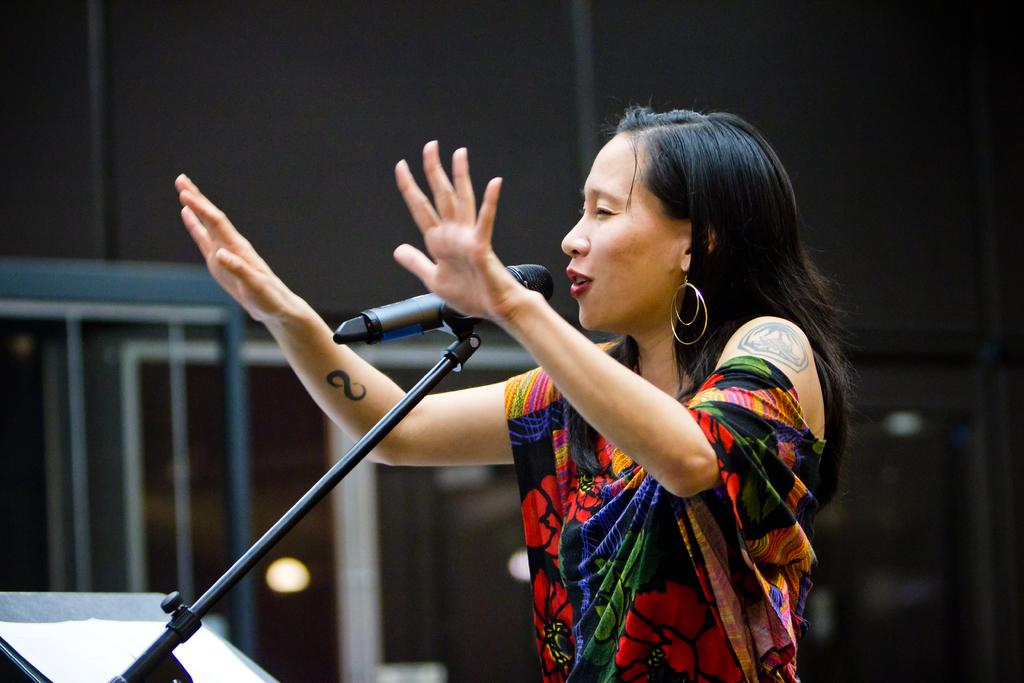Who is the main subject in the image? There is a lady in the image. What is the lady wearing? The lady is wearing a colorful dress. What is the lady doing in the image? The lady is talking on a mic. Are there any visible features on the lady's hands? Yes, the lady has tattoos on her hands. What can be seen in the background of the image? There is a building visible in the background of the image. How many goldfish are swimming in the lady's hair in the image? There are no goldfish present in the image, and the lady's hair is not mentioned in the provided facts. 